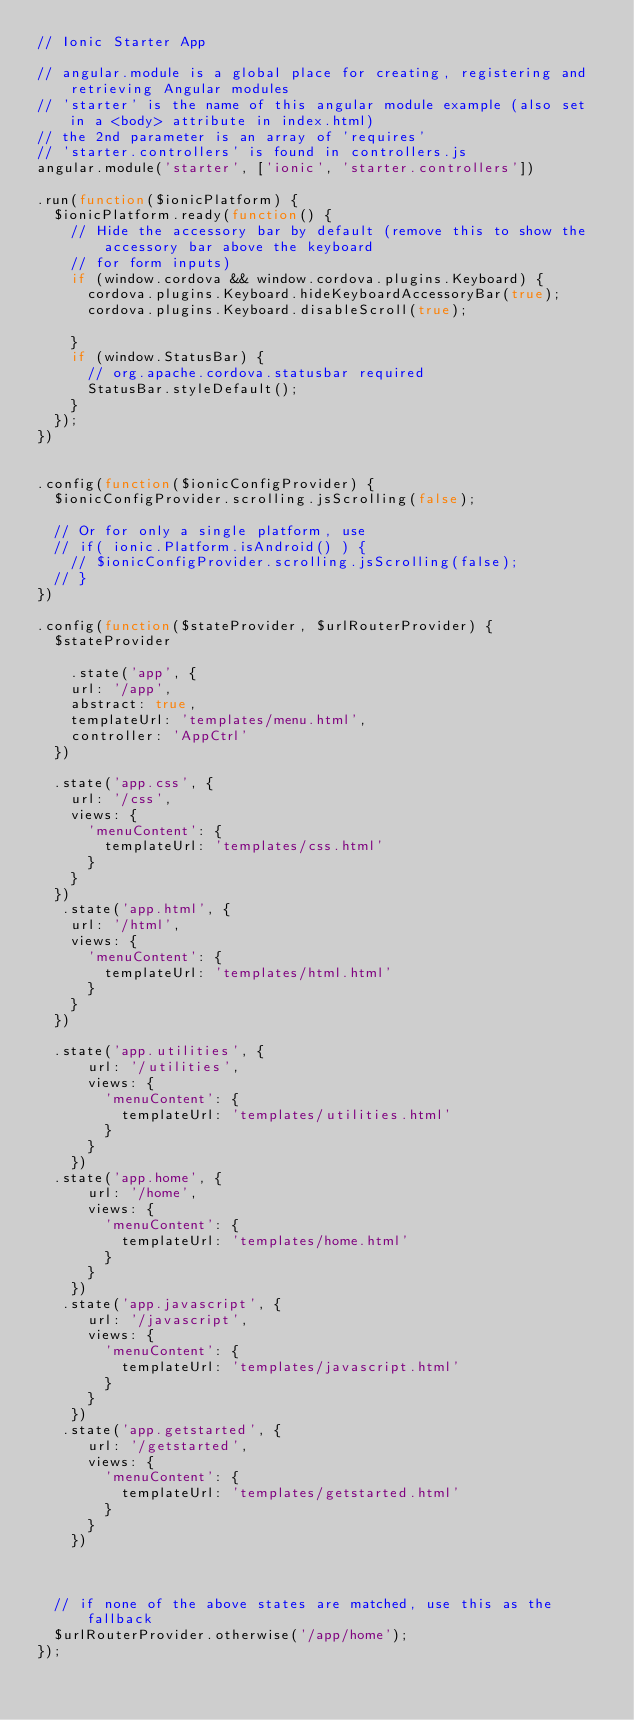Convert code to text. <code><loc_0><loc_0><loc_500><loc_500><_JavaScript_>// Ionic Starter App

// angular.module is a global place for creating, registering and retrieving Angular modules
// 'starter' is the name of this angular module example (also set in a <body> attribute in index.html)
// the 2nd parameter is an array of 'requires'
// 'starter.controllers' is found in controllers.js
angular.module('starter', ['ionic', 'starter.controllers'])

.run(function($ionicPlatform) {
  $ionicPlatform.ready(function() {
    // Hide the accessory bar by default (remove this to show the accessory bar above the keyboard
    // for form inputs)
    if (window.cordova && window.cordova.plugins.Keyboard) {
      cordova.plugins.Keyboard.hideKeyboardAccessoryBar(true);
      cordova.plugins.Keyboard.disableScroll(true);

    }
    if (window.StatusBar) {
      // org.apache.cordova.statusbar required
      StatusBar.styleDefault();
    }
  });
})


.config(function($ionicConfigProvider) {
  $ionicConfigProvider.scrolling.jsScrolling(false);
 
  // Or for only a single platform, use
  // if( ionic.Platform.isAndroid() ) {
    // $ionicConfigProvider.scrolling.jsScrolling(false);
  // }
})

.config(function($stateProvider, $urlRouterProvider) {
  $stateProvider

    .state('app', {
    url: '/app',
    abstract: true,
    templateUrl: 'templates/menu.html',
    controller: 'AppCtrl'
  })

  .state('app.css', {
    url: '/css',
    views: {
      'menuContent': {
        templateUrl: 'templates/css.html'
      }
    }
  })
   .state('app.html', {
    url: '/html',
    views: {
      'menuContent': {
        templateUrl: 'templates/html.html'
      }
    }
  })

  .state('app.utilities', {
      url: '/utilities',
      views: {
        'menuContent': {
          templateUrl: 'templates/utilities.html'
        }
      }
    })
  .state('app.home', {
      url: '/home',
      views: {
        'menuContent': {
          templateUrl: 'templates/home.html'
        }
      }
    })
   .state('app.javascript', {
      url: '/javascript',
      views: {
        'menuContent': {
          templateUrl: 'templates/javascript.html'
        }
      }
    })
   .state('app.getstarted', {
      url: '/getstarted',
      views: {
        'menuContent': {
          templateUrl: 'templates/getstarted.html'
        }
      }
    })
    

  
  // if none of the above states are matched, use this as the fallback
  $urlRouterProvider.otherwise('/app/home');
});
</code> 